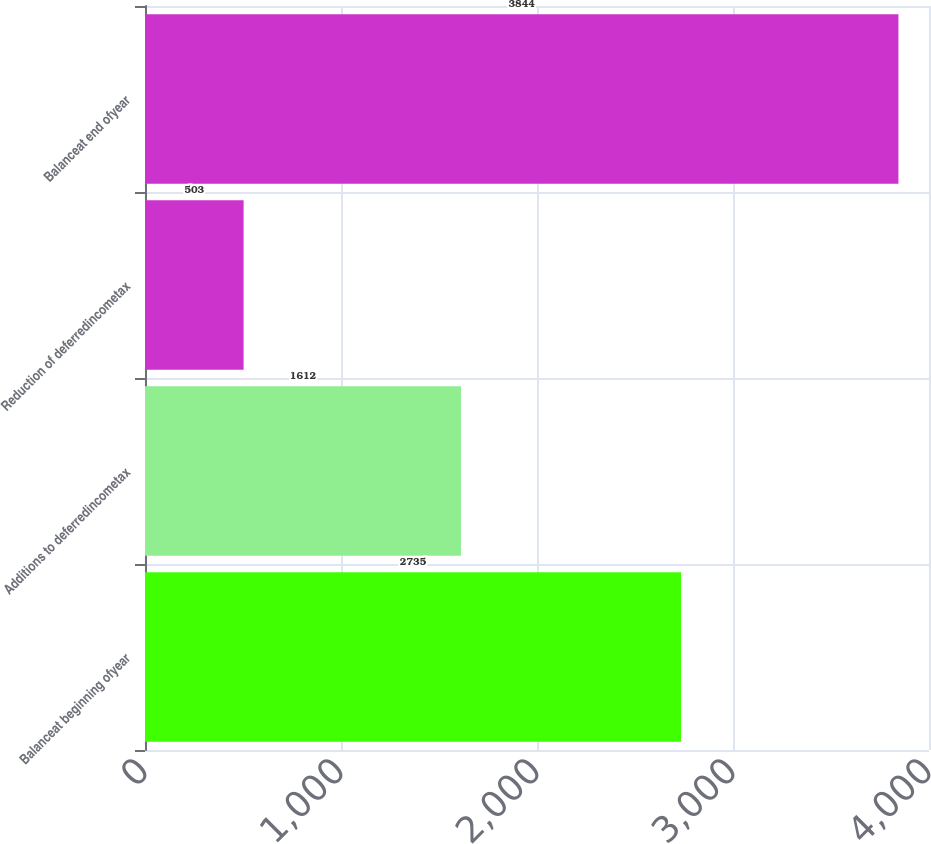<chart> <loc_0><loc_0><loc_500><loc_500><bar_chart><fcel>Balanceat beginning ofyear<fcel>Additions to deferredincometax<fcel>Reduction of deferredincometax<fcel>Balanceat end ofyear<nl><fcel>2735<fcel>1612<fcel>503<fcel>3844<nl></chart> 